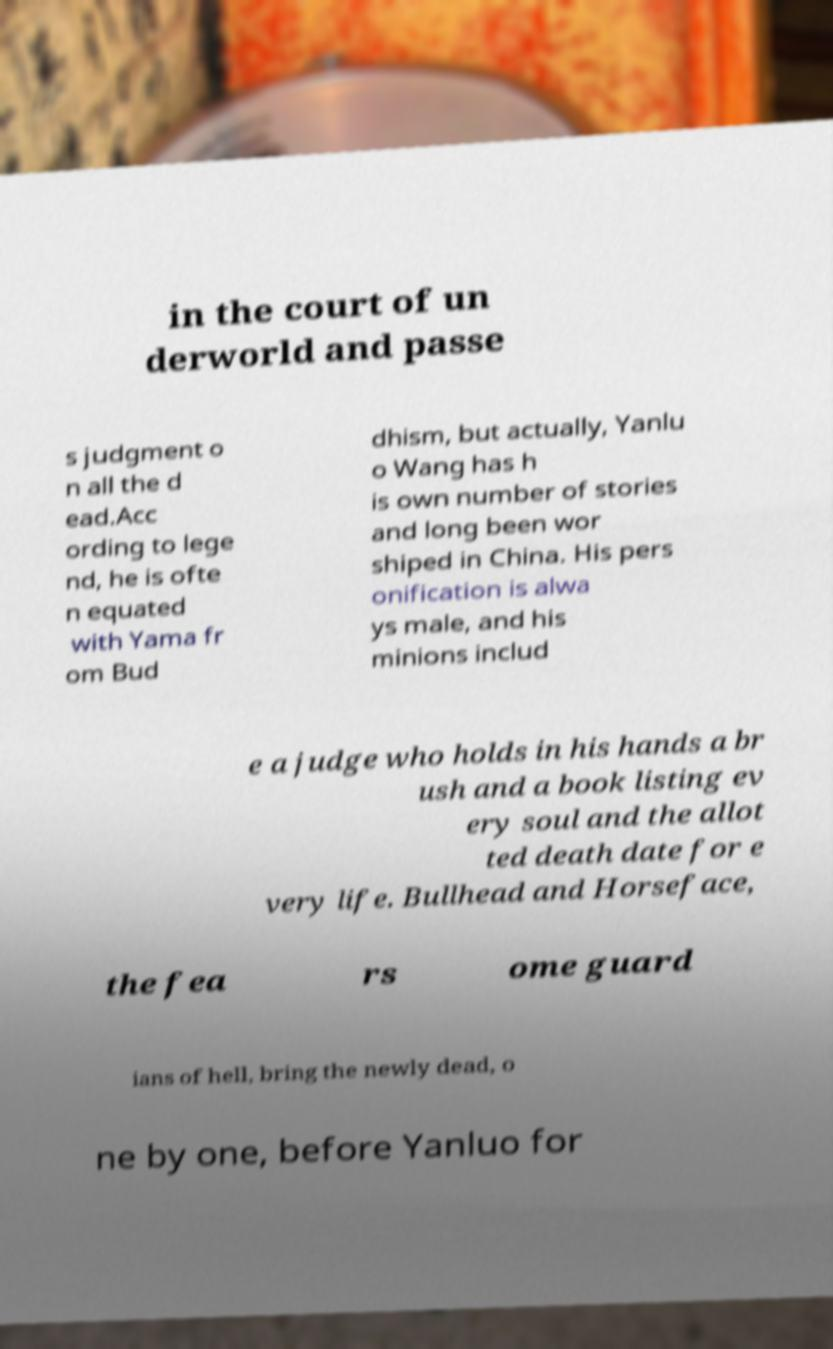For documentation purposes, I need the text within this image transcribed. Could you provide that? in the court of un derworld and passe s judgment o n all the d ead.Acc ording to lege nd, he is ofte n equated with Yama fr om Bud dhism, but actually, Yanlu o Wang has h is own number of stories and long been wor shiped in China. His pers onification is alwa ys male, and his minions includ e a judge who holds in his hands a br ush and a book listing ev ery soul and the allot ted death date for e very life. Bullhead and Horseface, the fea rs ome guard ians of hell, bring the newly dead, o ne by one, before Yanluo for 